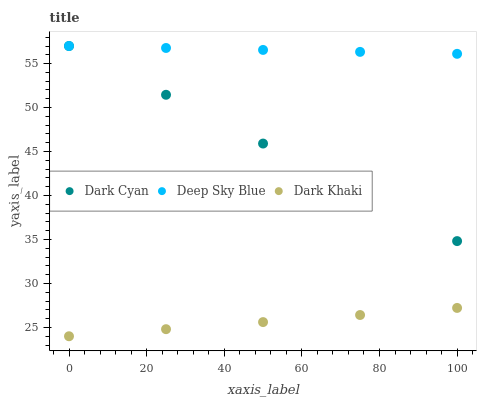Does Dark Khaki have the minimum area under the curve?
Answer yes or no. Yes. Does Deep Sky Blue have the maximum area under the curve?
Answer yes or no. Yes. Does Deep Sky Blue have the minimum area under the curve?
Answer yes or no. No. Does Dark Khaki have the maximum area under the curve?
Answer yes or no. No. Is Dark Khaki the smoothest?
Answer yes or no. Yes. Is Dark Cyan the roughest?
Answer yes or no. Yes. Is Deep Sky Blue the smoothest?
Answer yes or no. No. Is Deep Sky Blue the roughest?
Answer yes or no. No. Does Dark Khaki have the lowest value?
Answer yes or no. Yes. Does Deep Sky Blue have the lowest value?
Answer yes or no. No. Does Deep Sky Blue have the highest value?
Answer yes or no. Yes. Does Dark Khaki have the highest value?
Answer yes or no. No. Is Dark Khaki less than Dark Cyan?
Answer yes or no. Yes. Is Dark Cyan greater than Dark Khaki?
Answer yes or no. Yes. Does Deep Sky Blue intersect Dark Cyan?
Answer yes or no. Yes. Is Deep Sky Blue less than Dark Cyan?
Answer yes or no. No. Is Deep Sky Blue greater than Dark Cyan?
Answer yes or no. No. Does Dark Khaki intersect Dark Cyan?
Answer yes or no. No. 